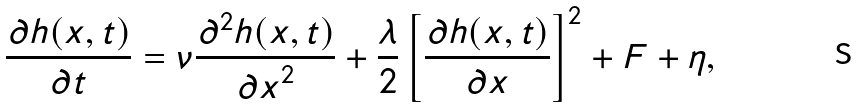Convert formula to latex. <formula><loc_0><loc_0><loc_500><loc_500>\frac { \partial h ( x , t ) } { \partial t } = \nu \frac { \partial ^ { 2 } h ( x , t ) } { { \partial x } ^ { 2 } } + \frac { \lambda } { 2 } \left [ \frac { \partial h ( x , t ) } { \partial x } \right ] ^ { 2 } + F + \eta ,</formula> 